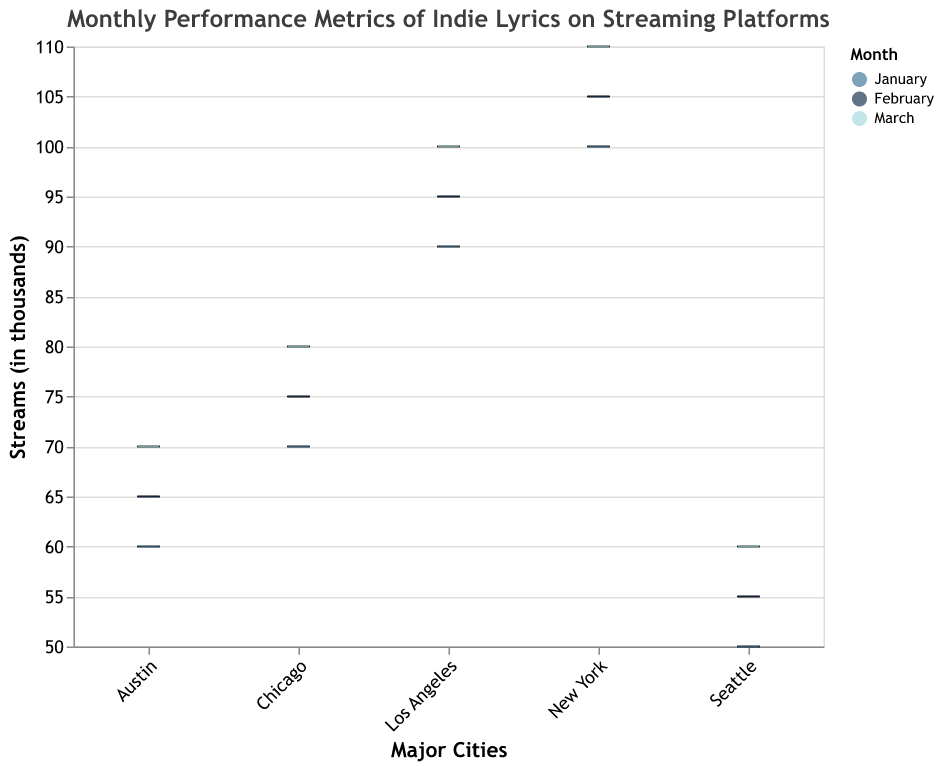What is the title of the figure? The title of the figure is displayed at the top of the chart. It reads, "Monthly Performance Metrics of Indie Lyrics on Streaming Platforms".
Answer: "Monthly Performance Metrics of Indie Lyrics on Streaming Platforms" How many cities are represented in the plot? The x-axis labels indicate the major cities represented in the figure. There are five cities: New York, Los Angeles, Chicago, Austin, and Seattle.
Answer: Five Which city had the highest median streams in January? Looking at the box plots for January, New York's median line is the highest compared to the other cities.
Answer: New York What is the median stream count for New York in March? The median stream count for New York in March can be found in the middle line of its respective box plot. It is 125 (thousands).
Answer: 125 Which city had the smallest range of streams in February? The range of streams is determined by the distance between the minimum and maximum values. Los Angeles in February has its minimum at 75 (thousands) and maximum at 145 (thousands), resulting in a smaller range compared to the other cities.
Answer: Los Angeles Which city shows the most consistent streaming performance across three months? Consistency can be observed by the interquartile ranges (IQR). New York shows relatively close Q1 and Q3 values over three months, indicating a consistent performance.
Answer: New York Compare the median streams for Austin in January and March. Which month had a higher median? The median in Austin is represented by the middle line in the box plot for each month. In January, it is 75 (thousands) and in March, it is 85 (thousands). Therefore, March had a higher median.
Answer: March What are the interquartile range (IQR) values for Seattle in February? The IQR is calculated as Q3 minus Q1. For Seattle in February, Q3 is 85 (thousands) and Q1 is 55 (thousands), so the IQR is 85 - 55.
Answer: 30 Which city had the lowest maximum stream count for any month? By examining the "max" whisker lines, Seattle in January shows the lowest maximum value of 100 (thousands).
Answer: Seattle Which month appears to have the highest average streaming counts across all cities? By observing the overall peaks and medians for each box plot, March generally seems to be higher, indicating higher average streams across all cities.
Answer: March 